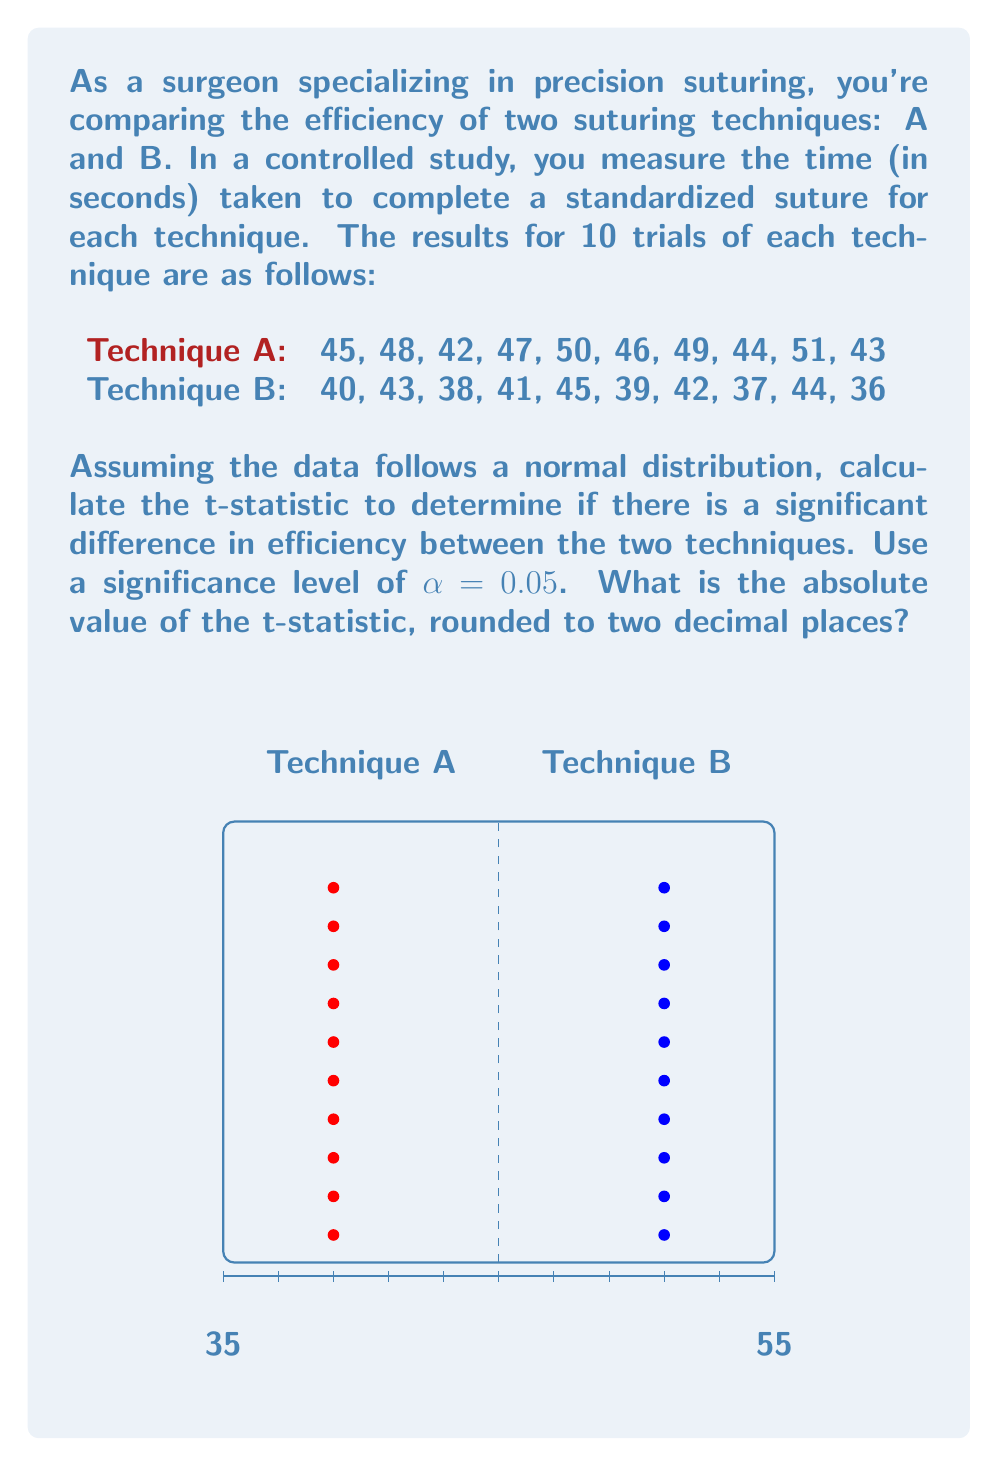Show me your answer to this math problem. To calculate the t-statistic, we'll follow these steps:

1) Calculate the means for each technique:

   $\bar{x}_A = \frac{45 + 48 + 42 + 47 + 50 + 46 + 49 + 44 + 51 + 43}{10} = 46.5$
   $\bar{x}_B = \frac{40 + 43 + 38 + 41 + 45 + 39 + 42 + 37 + 44 + 36}{10} = 40.5$

2) Calculate the standard deviations:

   For A: $s_A = \sqrt{\frac{\sum(x_i - \bar{x}_A)^2}{n-1}} = 3.0277$
   For B: $s_B = \sqrt{\frac{\sum(x_i - \bar{x}_B)^2}{n-1}} = 3.0277$

3) Calculate the pooled standard deviation:

   $s_p = \sqrt{\frac{(n_A-1)s_A^2 + (n_B-1)s_B^2}{n_A + n_B - 2}}$
   
   $s_p = \sqrt{\frac{(10-1)(3.0277)^2 + (10-1)(3.0277)^2}{10 + 10 - 2}} = 3.0277$

4) Calculate the t-statistic:

   $t = \frac{\bar{x}_A - \bar{x}_B}{s_p\sqrt{\frac{2}{n}}}$

   $t = \frac{46.5 - 40.5}{3.0277\sqrt{\frac{2}{10}}} = 4.6603$

5) Round to two decimal places:

   $|t| = 4.66$

This t-statistic can be compared to the critical t-value for a two-tailed test with 18 degrees of freedom (n1 + n2 - 2) and α = 0.05 to determine if there's a significant difference between the techniques.
Answer: 4.66 